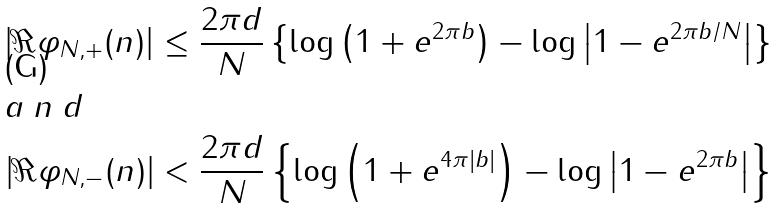Convert formula to latex. <formula><loc_0><loc_0><loc_500><loc_500>\left | \Re \varphi _ { N , + } ( n ) \right | \leq \frac { 2 \pi { d } } { N } \left \{ \log \left ( 1 + e ^ { 2 \pi { b } } \right ) - \log \left | 1 - e ^ { 2 \pi { b } / N } \right | \right \} \\ \intertext { a n d } \left | \Re \varphi _ { N , - } ( n ) \right | < \frac { 2 \pi { d } } { N } \left \{ \log \left ( 1 + e ^ { 4 \pi | b | } \right ) - \log \left | 1 - e ^ { 2 \pi { b } } \right | \right \}</formula> 